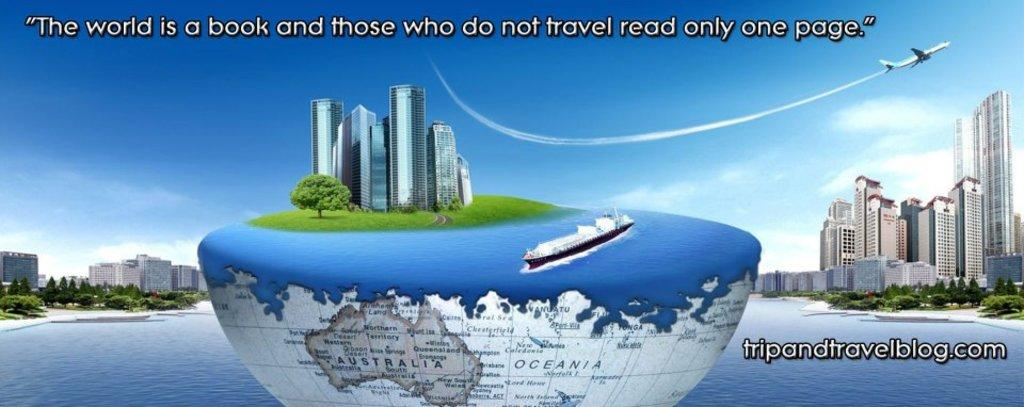What is the main feature of the image? There is a banner in the image. What types of images are present on the banner? The banner contains images of buildings, trees, water, a boat, and grass. How many brothers are depicted on the banner? There are no brothers depicted on the banner; it contains images of buildings, trees, water, a boat, and grass. What type of cable is connected to the boat on the banner? There is no cable connected to the boat on the banner; it is simply an image of a boat. 